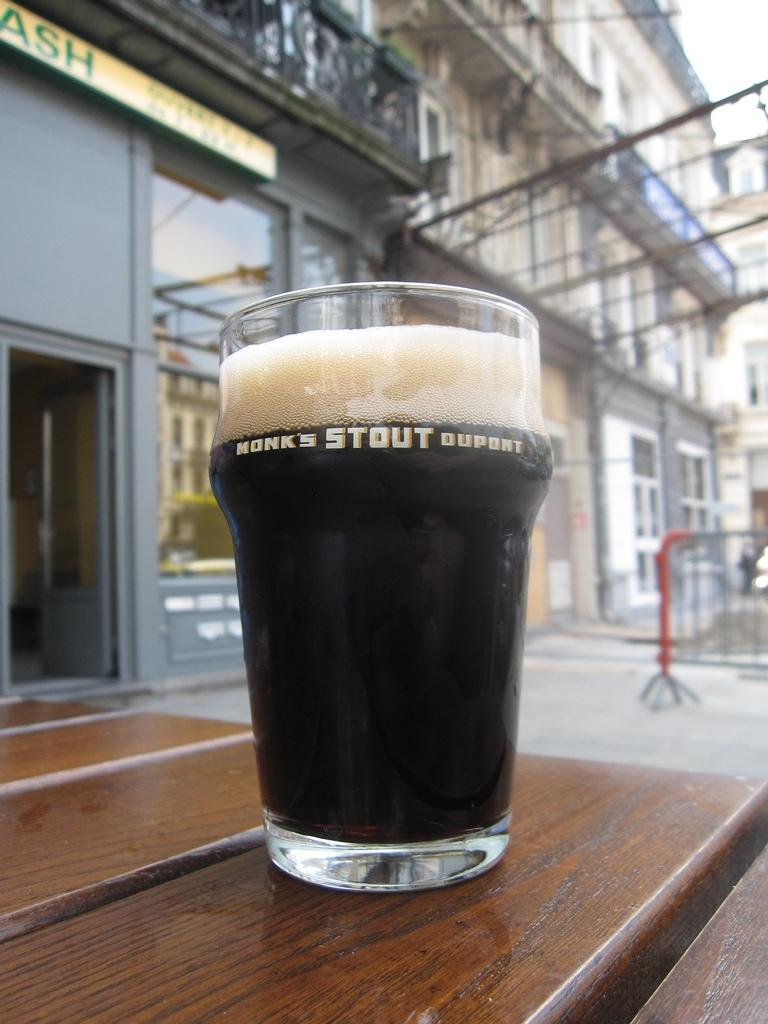<image>
Offer a succinct explanation of the picture presented. A Honk's Stout Dupont glass holds what appears to be a coke or root beer. 